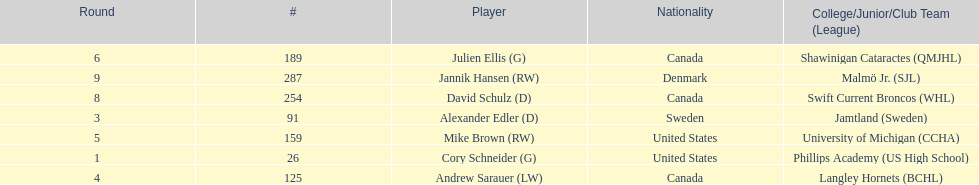What number of players have canada listed as their nationality? 3. 